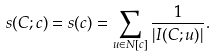Convert formula to latex. <formula><loc_0><loc_0><loc_500><loc_500>s ( C ; c ) = s ( c ) = \sum _ { u \in N [ c ] } \frac { 1 } { | I ( C ; u ) | } .</formula> 